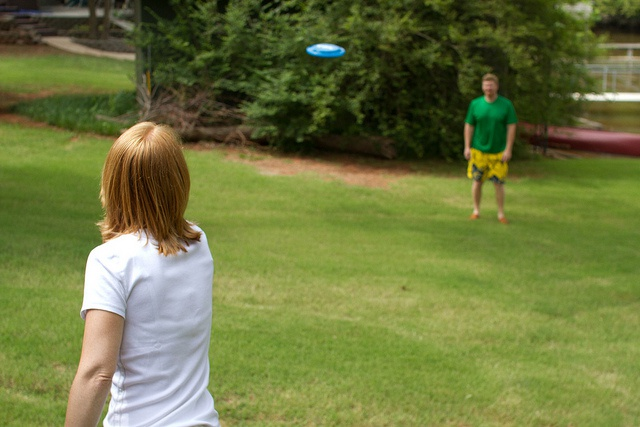Describe the objects in this image and their specific colors. I can see people in black, lavender, darkgray, and maroon tones, people in black, darkgreen, and olive tones, and frisbee in black, teal, and lightblue tones in this image. 